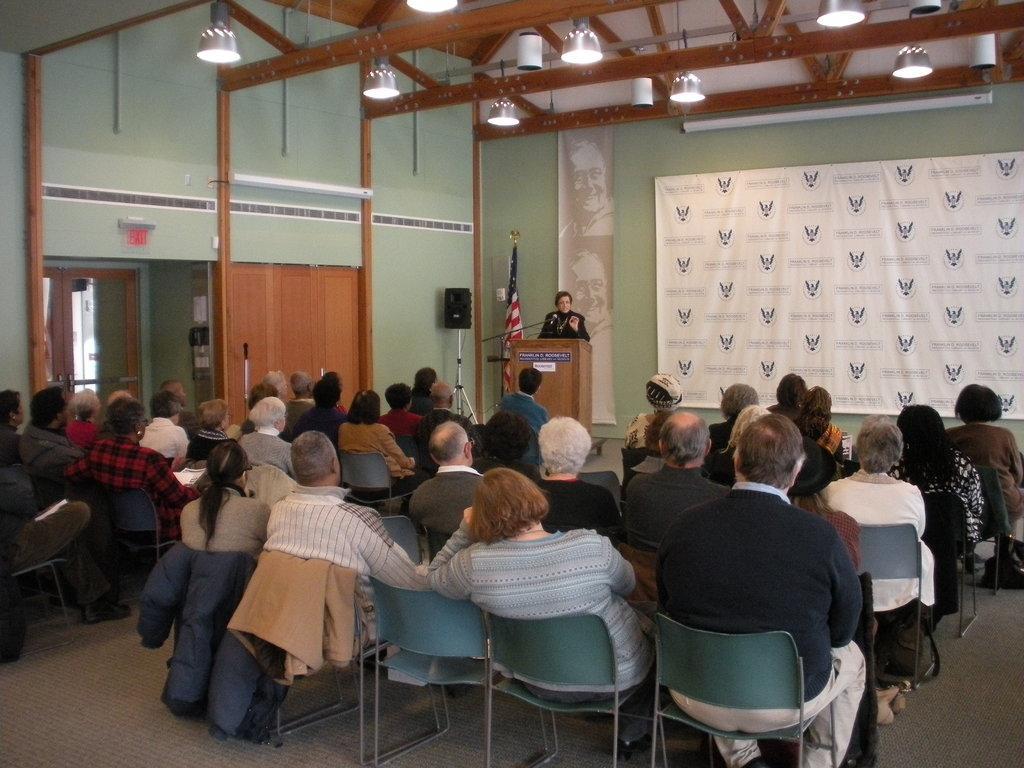In one or two sentences, can you explain what this image depicts? In the image we can see group of persons were sitting on the chair. And back we can see banners. One person standing in front of wood stand. And we can see flag,speaker,wall,lights and few objects. 